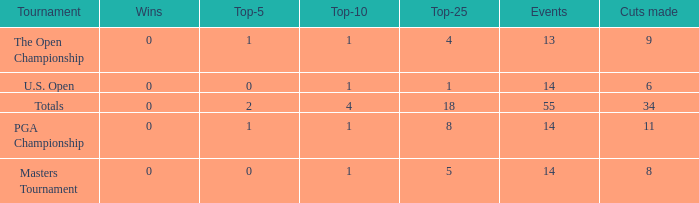What is the highest events when the cuts made is less than 34, the top-25 is less than 5 and the top-10 is more than 1? None. 